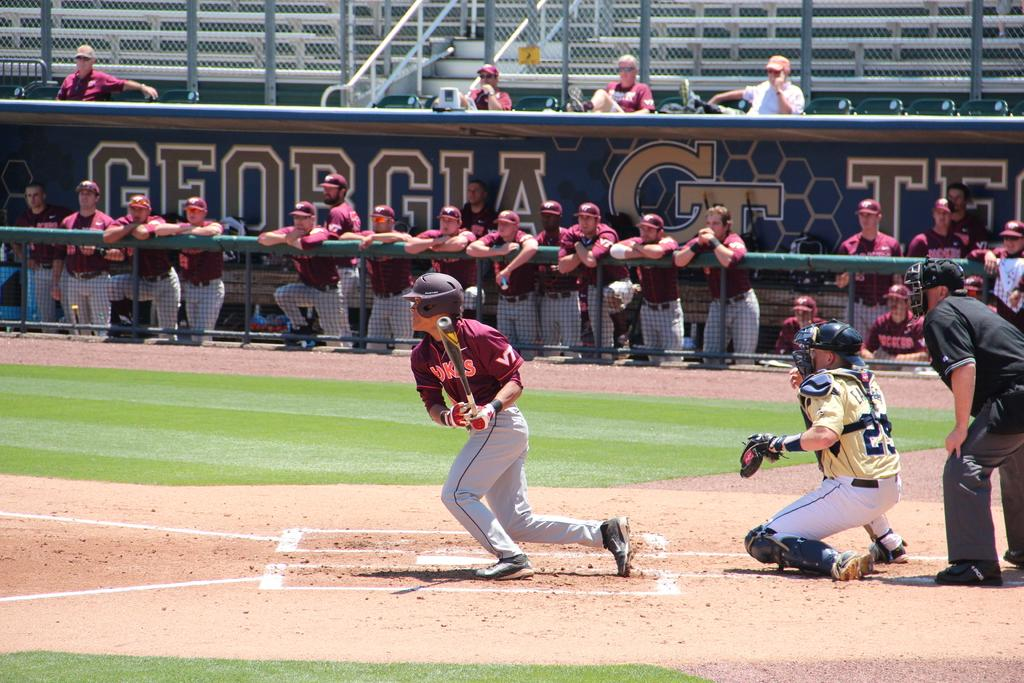Provide a one-sentence caption for the provided image. College baseball game Georgia Tech against the Hawks. 